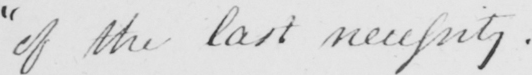Transcribe the text shown in this historical manuscript line. of the last necessity . _ 